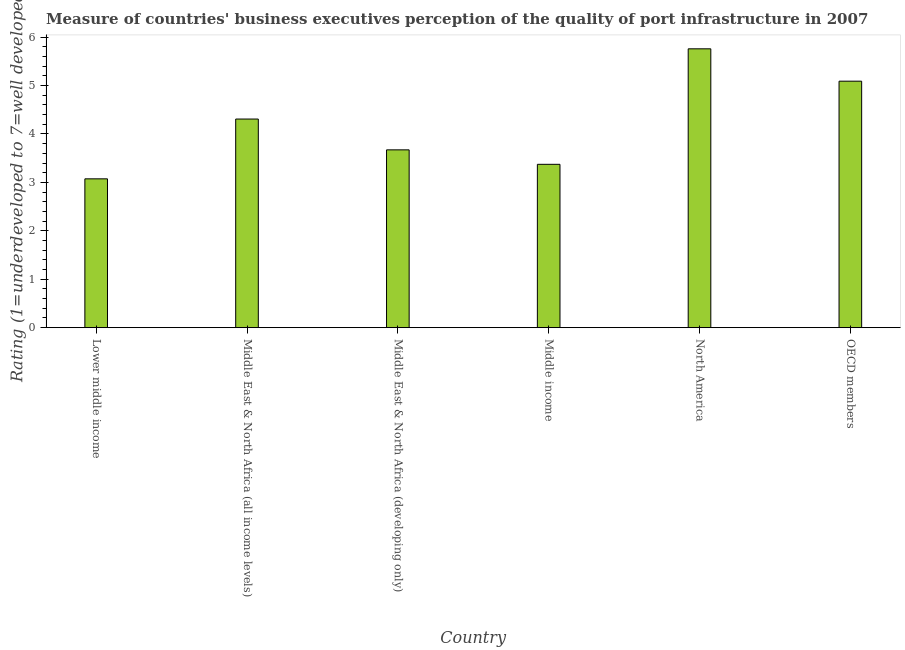Does the graph contain any zero values?
Your answer should be very brief. No. Does the graph contain grids?
Your answer should be very brief. No. What is the title of the graph?
Your response must be concise. Measure of countries' business executives perception of the quality of port infrastructure in 2007. What is the label or title of the X-axis?
Your response must be concise. Country. What is the label or title of the Y-axis?
Provide a short and direct response. Rating (1=underdeveloped to 7=well developed) . What is the rating measuring quality of port infrastructure in Lower middle income?
Keep it short and to the point. 3.07. Across all countries, what is the maximum rating measuring quality of port infrastructure?
Provide a succinct answer. 5.76. Across all countries, what is the minimum rating measuring quality of port infrastructure?
Offer a terse response. 3.07. In which country was the rating measuring quality of port infrastructure minimum?
Offer a very short reply. Lower middle income. What is the sum of the rating measuring quality of port infrastructure?
Offer a terse response. 25.27. What is the difference between the rating measuring quality of port infrastructure in Lower middle income and North America?
Make the answer very short. -2.69. What is the average rating measuring quality of port infrastructure per country?
Provide a short and direct response. 4.21. What is the median rating measuring quality of port infrastructure?
Offer a very short reply. 3.99. In how many countries, is the rating measuring quality of port infrastructure greater than 1.6 ?
Your answer should be compact. 6. What is the ratio of the rating measuring quality of port infrastructure in Lower middle income to that in North America?
Give a very brief answer. 0.53. What is the difference between the highest and the second highest rating measuring quality of port infrastructure?
Ensure brevity in your answer.  0.67. Is the sum of the rating measuring quality of port infrastructure in Lower middle income and Middle East & North Africa (all income levels) greater than the maximum rating measuring quality of port infrastructure across all countries?
Your answer should be compact. Yes. What is the difference between the highest and the lowest rating measuring quality of port infrastructure?
Provide a short and direct response. 2.68. In how many countries, is the rating measuring quality of port infrastructure greater than the average rating measuring quality of port infrastructure taken over all countries?
Keep it short and to the point. 3. How many bars are there?
Ensure brevity in your answer.  6. Are all the bars in the graph horizontal?
Provide a short and direct response. No. How many countries are there in the graph?
Offer a very short reply. 6. Are the values on the major ticks of Y-axis written in scientific E-notation?
Offer a terse response. No. What is the Rating (1=underdeveloped to 7=well developed)  in Lower middle income?
Provide a short and direct response. 3.07. What is the Rating (1=underdeveloped to 7=well developed)  in Middle East & North Africa (all income levels)?
Provide a short and direct response. 4.31. What is the Rating (1=underdeveloped to 7=well developed)  of Middle East & North Africa (developing only)?
Keep it short and to the point. 3.67. What is the Rating (1=underdeveloped to 7=well developed)  in Middle income?
Offer a terse response. 3.37. What is the Rating (1=underdeveloped to 7=well developed)  in North America?
Your response must be concise. 5.76. What is the Rating (1=underdeveloped to 7=well developed)  in OECD members?
Your answer should be compact. 5.09. What is the difference between the Rating (1=underdeveloped to 7=well developed)  in Lower middle income and Middle East & North Africa (all income levels)?
Provide a succinct answer. -1.23. What is the difference between the Rating (1=underdeveloped to 7=well developed)  in Lower middle income and Middle East & North Africa (developing only)?
Your answer should be compact. -0.6. What is the difference between the Rating (1=underdeveloped to 7=well developed)  in Lower middle income and Middle income?
Your answer should be compact. -0.3. What is the difference between the Rating (1=underdeveloped to 7=well developed)  in Lower middle income and North America?
Offer a terse response. -2.68. What is the difference between the Rating (1=underdeveloped to 7=well developed)  in Lower middle income and OECD members?
Keep it short and to the point. -2.02. What is the difference between the Rating (1=underdeveloped to 7=well developed)  in Middle East & North Africa (all income levels) and Middle East & North Africa (developing only)?
Your response must be concise. 0.64. What is the difference between the Rating (1=underdeveloped to 7=well developed)  in Middle East & North Africa (all income levels) and Middle income?
Offer a very short reply. 0.94. What is the difference between the Rating (1=underdeveloped to 7=well developed)  in Middle East & North Africa (all income levels) and North America?
Your response must be concise. -1.45. What is the difference between the Rating (1=underdeveloped to 7=well developed)  in Middle East & North Africa (all income levels) and OECD members?
Ensure brevity in your answer.  -0.78. What is the difference between the Rating (1=underdeveloped to 7=well developed)  in Middle East & North Africa (developing only) and Middle income?
Offer a very short reply. 0.3. What is the difference between the Rating (1=underdeveloped to 7=well developed)  in Middle East & North Africa (developing only) and North America?
Your answer should be compact. -2.09. What is the difference between the Rating (1=underdeveloped to 7=well developed)  in Middle East & North Africa (developing only) and OECD members?
Offer a terse response. -1.42. What is the difference between the Rating (1=underdeveloped to 7=well developed)  in Middle income and North America?
Ensure brevity in your answer.  -2.39. What is the difference between the Rating (1=underdeveloped to 7=well developed)  in Middle income and OECD members?
Your answer should be compact. -1.72. What is the difference between the Rating (1=underdeveloped to 7=well developed)  in North America and OECD members?
Your response must be concise. 0.67. What is the ratio of the Rating (1=underdeveloped to 7=well developed)  in Lower middle income to that in Middle East & North Africa (all income levels)?
Your answer should be very brief. 0.71. What is the ratio of the Rating (1=underdeveloped to 7=well developed)  in Lower middle income to that in Middle East & North Africa (developing only)?
Your answer should be very brief. 0.84. What is the ratio of the Rating (1=underdeveloped to 7=well developed)  in Lower middle income to that in Middle income?
Keep it short and to the point. 0.91. What is the ratio of the Rating (1=underdeveloped to 7=well developed)  in Lower middle income to that in North America?
Offer a very short reply. 0.53. What is the ratio of the Rating (1=underdeveloped to 7=well developed)  in Lower middle income to that in OECD members?
Keep it short and to the point. 0.6. What is the ratio of the Rating (1=underdeveloped to 7=well developed)  in Middle East & North Africa (all income levels) to that in Middle East & North Africa (developing only)?
Provide a succinct answer. 1.17. What is the ratio of the Rating (1=underdeveloped to 7=well developed)  in Middle East & North Africa (all income levels) to that in Middle income?
Offer a terse response. 1.28. What is the ratio of the Rating (1=underdeveloped to 7=well developed)  in Middle East & North Africa (all income levels) to that in North America?
Make the answer very short. 0.75. What is the ratio of the Rating (1=underdeveloped to 7=well developed)  in Middle East & North Africa (all income levels) to that in OECD members?
Your answer should be very brief. 0.85. What is the ratio of the Rating (1=underdeveloped to 7=well developed)  in Middle East & North Africa (developing only) to that in Middle income?
Offer a very short reply. 1.09. What is the ratio of the Rating (1=underdeveloped to 7=well developed)  in Middle East & North Africa (developing only) to that in North America?
Your answer should be very brief. 0.64. What is the ratio of the Rating (1=underdeveloped to 7=well developed)  in Middle East & North Africa (developing only) to that in OECD members?
Your answer should be compact. 0.72. What is the ratio of the Rating (1=underdeveloped to 7=well developed)  in Middle income to that in North America?
Provide a succinct answer. 0.59. What is the ratio of the Rating (1=underdeveloped to 7=well developed)  in Middle income to that in OECD members?
Your answer should be compact. 0.66. What is the ratio of the Rating (1=underdeveloped to 7=well developed)  in North America to that in OECD members?
Offer a terse response. 1.13. 